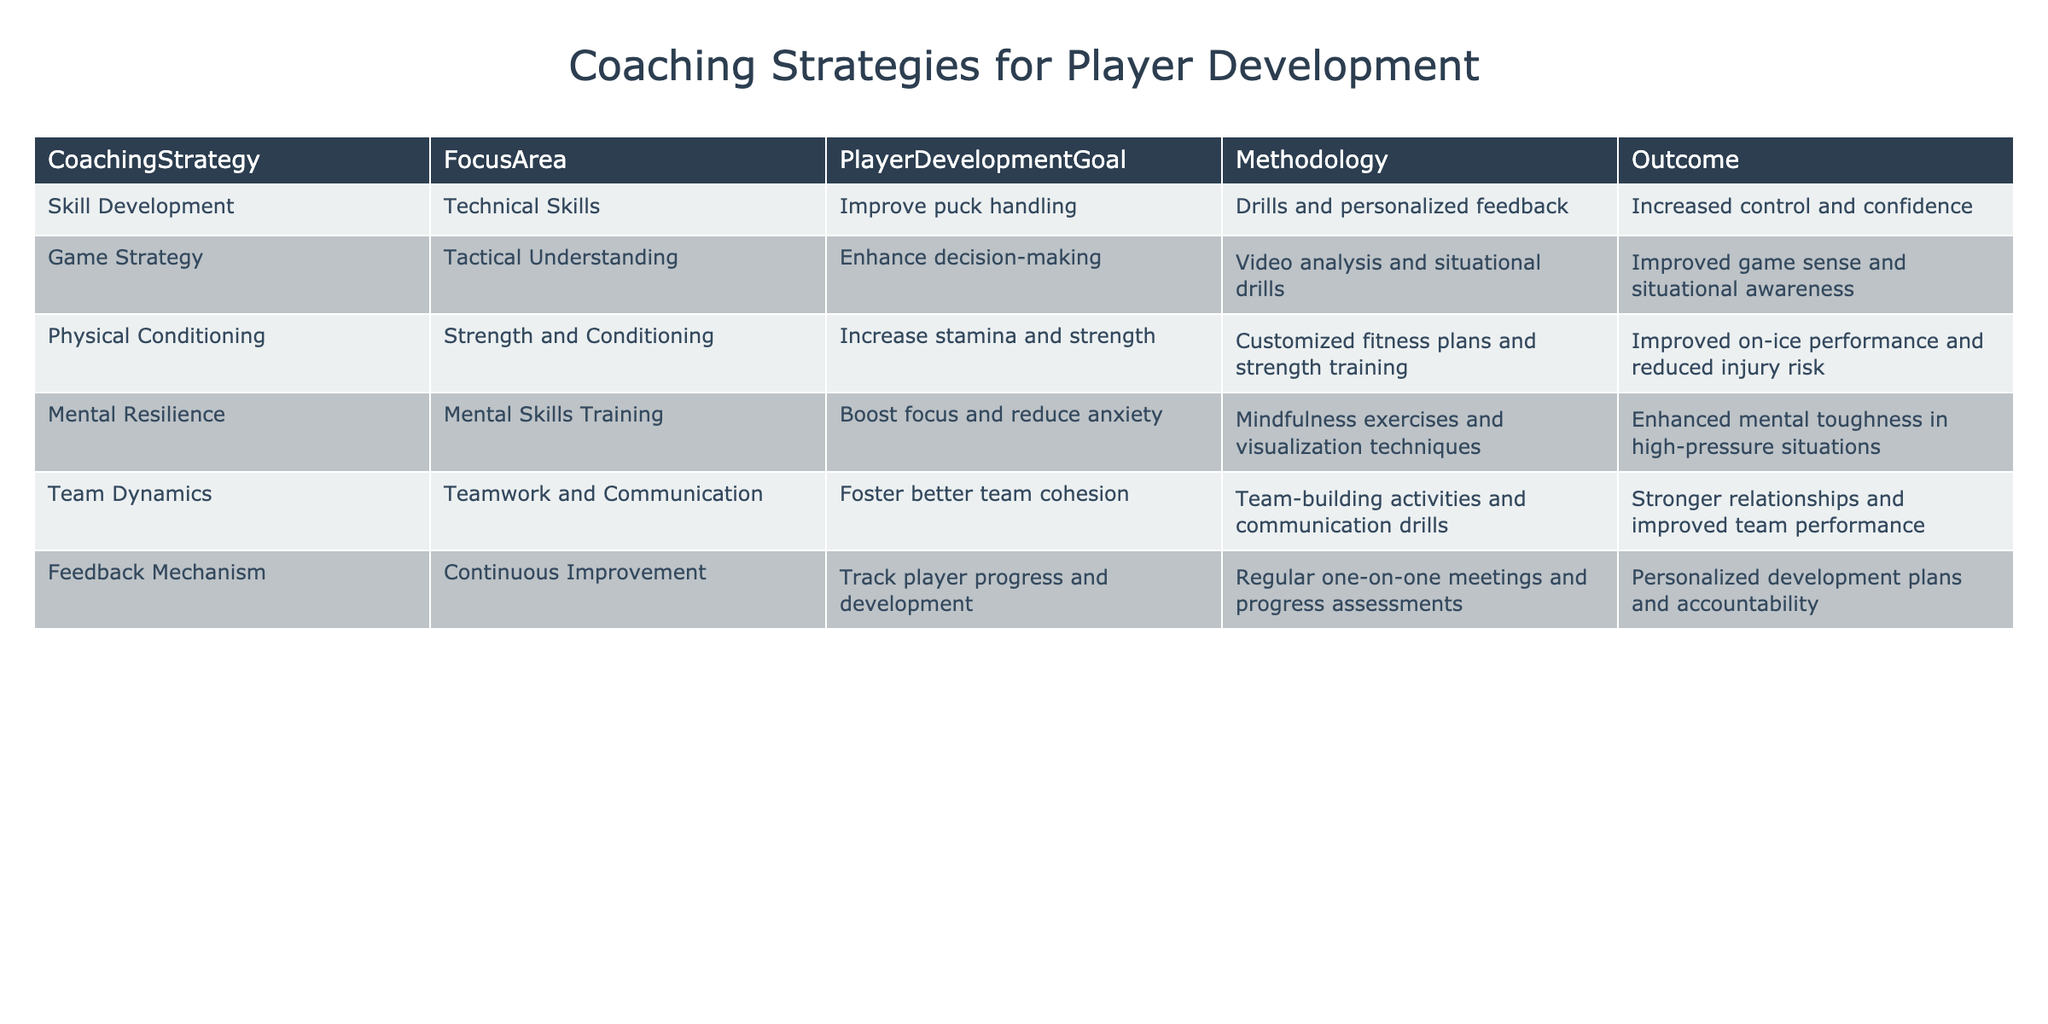What is the methodology used to improve puck handling? Referring to the "Skill Development" row in the table, the methodology employed is "Drills and personalized feedback."
Answer: Drills and personalized feedback Which focus area aims to enhance decision-making? In the table, the "Game Strategy" row specifies that enhancing decision-making is the goal of the "Tactical Understanding" focus area.
Answer: Tactical Understanding Is there a strategy aimed at improving team communication? Yes, the "Team Dynamics" strategy focuses explicitly on fostering better team communication.
Answer: Yes What is the outcome of the Physical Conditioning strategy? The outcome listed for the "Physical Conditioning" strategy is "Improved on-ice performance and reduced injury risk."
Answer: Improved on-ice performance and reduced injury risk Which strategy uses mindfulness exercises? The "Mental Resilience" strategy implements mindfulness exercises, as stated in its methodology.
Answer: Mental Resilience What is the relationship between the focus area and the player development goal in the Game Strategy category? The focus area for the "Game Strategy" is "Tactical Understanding," which directly relates to the player development goal of enhancing decision-making, showing a connection between the two.
Answer: Enhancing decision-making How many unique player development goals are listed in the table? There are five unique player development goals corresponding to the different strategies: Improving puck handling, Enhancing decision-making, Increasing stamina and strength, Boosting focus and reducing anxiety, and Fostering better team cohesion. Counting each, we find a total of five goals.
Answer: Five What is the outcome associated with the Feedback Mechanism strategy? The outcome for the "Feedback Mechanism" strategy is "Personalized development plans and accountability," as stated in the respective row of the table.
Answer: Personalized development plans and accountability If you combine the goals of the Skill Development and Mental Resilience strategies, what general player attributes might be enhanced? The Skill Development goal, which is to improve puck handling, supports technical skill growth, while the Mental Resilience goal, intended to boost focus and reduce anxiety, suggests mental fortitude. Therefore, combining these two would enhance both technical and mental attributes for players.
Answer: Technical and mental attributes How many strategies include the goal of improving overall player performance? The strategies of "Physical Conditioning," "Mental Resilience," and "Feedback Mechanism" all include goals that ultimately aim to enhance player performance through various means. Summing these gives us a total of three strategies.
Answer: Three 